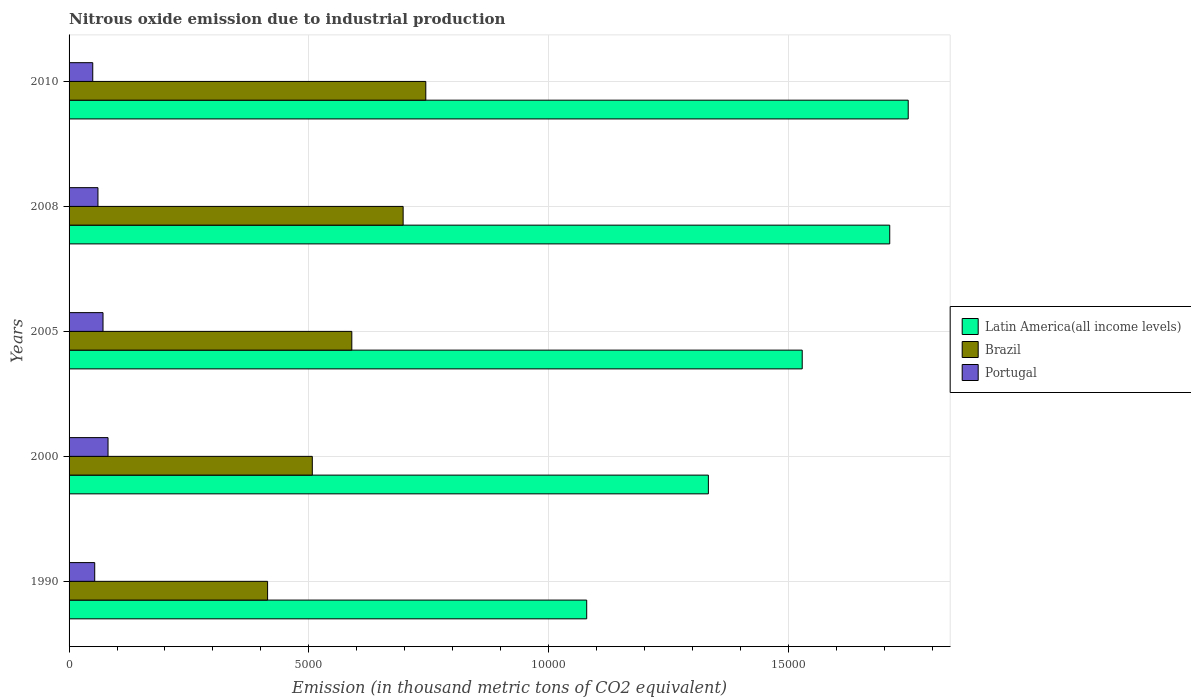How many different coloured bars are there?
Offer a terse response. 3. How many groups of bars are there?
Provide a succinct answer. 5. How many bars are there on the 5th tick from the top?
Give a very brief answer. 3. How many bars are there on the 2nd tick from the bottom?
Provide a short and direct response. 3. In how many cases, is the number of bars for a given year not equal to the number of legend labels?
Your answer should be compact. 0. What is the amount of nitrous oxide emitted in Latin America(all income levels) in 1990?
Offer a terse response. 1.08e+04. Across all years, what is the maximum amount of nitrous oxide emitted in Brazil?
Keep it short and to the point. 7440.7. Across all years, what is the minimum amount of nitrous oxide emitted in Latin America(all income levels)?
Your answer should be compact. 1.08e+04. In which year was the amount of nitrous oxide emitted in Portugal maximum?
Offer a very short reply. 2000. In which year was the amount of nitrous oxide emitted in Latin America(all income levels) minimum?
Ensure brevity in your answer.  1990. What is the total amount of nitrous oxide emitted in Latin America(all income levels) in the graph?
Offer a very short reply. 7.40e+04. What is the difference between the amount of nitrous oxide emitted in Latin America(all income levels) in 2005 and that in 2008?
Your response must be concise. -1825.4. What is the difference between the amount of nitrous oxide emitted in Brazil in 2010 and the amount of nitrous oxide emitted in Latin America(all income levels) in 2005?
Offer a very short reply. -7851.4. What is the average amount of nitrous oxide emitted in Latin America(all income levels) per year?
Your response must be concise. 1.48e+04. In the year 2005, what is the difference between the amount of nitrous oxide emitted in Latin America(all income levels) and amount of nitrous oxide emitted in Portugal?
Give a very brief answer. 1.46e+04. What is the ratio of the amount of nitrous oxide emitted in Latin America(all income levels) in 1990 to that in 2005?
Provide a succinct answer. 0.71. Is the difference between the amount of nitrous oxide emitted in Latin America(all income levels) in 2008 and 2010 greater than the difference between the amount of nitrous oxide emitted in Portugal in 2008 and 2010?
Provide a succinct answer. No. What is the difference between the highest and the second highest amount of nitrous oxide emitted in Brazil?
Provide a succinct answer. 472.8. What is the difference between the highest and the lowest amount of nitrous oxide emitted in Latin America(all income levels)?
Offer a terse response. 6706.3. In how many years, is the amount of nitrous oxide emitted in Portugal greater than the average amount of nitrous oxide emitted in Portugal taken over all years?
Keep it short and to the point. 2. What does the 2nd bar from the top in 2010 represents?
Your answer should be compact. Brazil. How many bars are there?
Your answer should be compact. 15. Are all the bars in the graph horizontal?
Offer a terse response. Yes. How many years are there in the graph?
Ensure brevity in your answer.  5. Are the values on the major ticks of X-axis written in scientific E-notation?
Your answer should be compact. No. Where does the legend appear in the graph?
Your answer should be very brief. Center right. How many legend labels are there?
Offer a very short reply. 3. What is the title of the graph?
Provide a short and direct response. Nitrous oxide emission due to industrial production. Does "East Asia (all income levels)" appear as one of the legend labels in the graph?
Make the answer very short. No. What is the label or title of the X-axis?
Offer a very short reply. Emission (in thousand metric tons of CO2 equivalent). What is the Emission (in thousand metric tons of CO2 equivalent) in Latin America(all income levels) in 1990?
Your answer should be compact. 1.08e+04. What is the Emission (in thousand metric tons of CO2 equivalent) in Brazil in 1990?
Make the answer very short. 4140.8. What is the Emission (in thousand metric tons of CO2 equivalent) of Portugal in 1990?
Give a very brief answer. 534.9. What is the Emission (in thousand metric tons of CO2 equivalent) of Latin America(all income levels) in 2000?
Provide a succinct answer. 1.33e+04. What is the Emission (in thousand metric tons of CO2 equivalent) in Brazil in 2000?
Ensure brevity in your answer.  5073.4. What is the Emission (in thousand metric tons of CO2 equivalent) in Portugal in 2000?
Give a very brief answer. 812.7. What is the Emission (in thousand metric tons of CO2 equivalent) of Latin America(all income levels) in 2005?
Provide a succinct answer. 1.53e+04. What is the Emission (in thousand metric tons of CO2 equivalent) of Brazil in 2005?
Your answer should be very brief. 5897.3. What is the Emission (in thousand metric tons of CO2 equivalent) in Portugal in 2005?
Provide a short and direct response. 708. What is the Emission (in thousand metric tons of CO2 equivalent) in Latin America(all income levels) in 2008?
Offer a very short reply. 1.71e+04. What is the Emission (in thousand metric tons of CO2 equivalent) in Brazil in 2008?
Offer a very short reply. 6967.9. What is the Emission (in thousand metric tons of CO2 equivalent) in Portugal in 2008?
Your answer should be very brief. 602.5. What is the Emission (in thousand metric tons of CO2 equivalent) of Latin America(all income levels) in 2010?
Your response must be concise. 1.75e+04. What is the Emission (in thousand metric tons of CO2 equivalent) of Brazil in 2010?
Ensure brevity in your answer.  7440.7. What is the Emission (in thousand metric tons of CO2 equivalent) in Portugal in 2010?
Your response must be concise. 494. Across all years, what is the maximum Emission (in thousand metric tons of CO2 equivalent) of Latin America(all income levels)?
Keep it short and to the point. 1.75e+04. Across all years, what is the maximum Emission (in thousand metric tons of CO2 equivalent) in Brazil?
Give a very brief answer. 7440.7. Across all years, what is the maximum Emission (in thousand metric tons of CO2 equivalent) of Portugal?
Your answer should be compact. 812.7. Across all years, what is the minimum Emission (in thousand metric tons of CO2 equivalent) in Latin America(all income levels)?
Your response must be concise. 1.08e+04. Across all years, what is the minimum Emission (in thousand metric tons of CO2 equivalent) in Brazil?
Your answer should be very brief. 4140.8. Across all years, what is the minimum Emission (in thousand metric tons of CO2 equivalent) of Portugal?
Your answer should be compact. 494. What is the total Emission (in thousand metric tons of CO2 equivalent) of Latin America(all income levels) in the graph?
Offer a terse response. 7.40e+04. What is the total Emission (in thousand metric tons of CO2 equivalent) in Brazil in the graph?
Provide a succinct answer. 2.95e+04. What is the total Emission (in thousand metric tons of CO2 equivalent) in Portugal in the graph?
Ensure brevity in your answer.  3152.1. What is the difference between the Emission (in thousand metric tons of CO2 equivalent) in Latin America(all income levels) in 1990 and that in 2000?
Your response must be concise. -2538. What is the difference between the Emission (in thousand metric tons of CO2 equivalent) of Brazil in 1990 and that in 2000?
Offer a terse response. -932.6. What is the difference between the Emission (in thousand metric tons of CO2 equivalent) in Portugal in 1990 and that in 2000?
Your answer should be compact. -277.8. What is the difference between the Emission (in thousand metric tons of CO2 equivalent) in Latin America(all income levels) in 1990 and that in 2005?
Ensure brevity in your answer.  -4495.3. What is the difference between the Emission (in thousand metric tons of CO2 equivalent) of Brazil in 1990 and that in 2005?
Ensure brevity in your answer.  -1756.5. What is the difference between the Emission (in thousand metric tons of CO2 equivalent) of Portugal in 1990 and that in 2005?
Offer a very short reply. -173.1. What is the difference between the Emission (in thousand metric tons of CO2 equivalent) of Latin America(all income levels) in 1990 and that in 2008?
Give a very brief answer. -6320.7. What is the difference between the Emission (in thousand metric tons of CO2 equivalent) in Brazil in 1990 and that in 2008?
Give a very brief answer. -2827.1. What is the difference between the Emission (in thousand metric tons of CO2 equivalent) of Portugal in 1990 and that in 2008?
Provide a short and direct response. -67.6. What is the difference between the Emission (in thousand metric tons of CO2 equivalent) in Latin America(all income levels) in 1990 and that in 2010?
Make the answer very short. -6706.3. What is the difference between the Emission (in thousand metric tons of CO2 equivalent) of Brazil in 1990 and that in 2010?
Provide a short and direct response. -3299.9. What is the difference between the Emission (in thousand metric tons of CO2 equivalent) in Portugal in 1990 and that in 2010?
Provide a short and direct response. 40.9. What is the difference between the Emission (in thousand metric tons of CO2 equivalent) in Latin America(all income levels) in 2000 and that in 2005?
Your response must be concise. -1957.3. What is the difference between the Emission (in thousand metric tons of CO2 equivalent) in Brazil in 2000 and that in 2005?
Offer a very short reply. -823.9. What is the difference between the Emission (in thousand metric tons of CO2 equivalent) of Portugal in 2000 and that in 2005?
Provide a succinct answer. 104.7. What is the difference between the Emission (in thousand metric tons of CO2 equivalent) of Latin America(all income levels) in 2000 and that in 2008?
Offer a very short reply. -3782.7. What is the difference between the Emission (in thousand metric tons of CO2 equivalent) in Brazil in 2000 and that in 2008?
Make the answer very short. -1894.5. What is the difference between the Emission (in thousand metric tons of CO2 equivalent) of Portugal in 2000 and that in 2008?
Provide a short and direct response. 210.2. What is the difference between the Emission (in thousand metric tons of CO2 equivalent) of Latin America(all income levels) in 2000 and that in 2010?
Offer a terse response. -4168.3. What is the difference between the Emission (in thousand metric tons of CO2 equivalent) of Brazil in 2000 and that in 2010?
Provide a succinct answer. -2367.3. What is the difference between the Emission (in thousand metric tons of CO2 equivalent) of Portugal in 2000 and that in 2010?
Provide a short and direct response. 318.7. What is the difference between the Emission (in thousand metric tons of CO2 equivalent) of Latin America(all income levels) in 2005 and that in 2008?
Your answer should be very brief. -1825.4. What is the difference between the Emission (in thousand metric tons of CO2 equivalent) of Brazil in 2005 and that in 2008?
Offer a terse response. -1070.6. What is the difference between the Emission (in thousand metric tons of CO2 equivalent) in Portugal in 2005 and that in 2008?
Your answer should be very brief. 105.5. What is the difference between the Emission (in thousand metric tons of CO2 equivalent) in Latin America(all income levels) in 2005 and that in 2010?
Provide a short and direct response. -2211. What is the difference between the Emission (in thousand metric tons of CO2 equivalent) in Brazil in 2005 and that in 2010?
Make the answer very short. -1543.4. What is the difference between the Emission (in thousand metric tons of CO2 equivalent) in Portugal in 2005 and that in 2010?
Provide a short and direct response. 214. What is the difference between the Emission (in thousand metric tons of CO2 equivalent) of Latin America(all income levels) in 2008 and that in 2010?
Offer a terse response. -385.6. What is the difference between the Emission (in thousand metric tons of CO2 equivalent) of Brazil in 2008 and that in 2010?
Your answer should be very brief. -472.8. What is the difference between the Emission (in thousand metric tons of CO2 equivalent) in Portugal in 2008 and that in 2010?
Provide a succinct answer. 108.5. What is the difference between the Emission (in thousand metric tons of CO2 equivalent) in Latin America(all income levels) in 1990 and the Emission (in thousand metric tons of CO2 equivalent) in Brazil in 2000?
Offer a terse response. 5723.4. What is the difference between the Emission (in thousand metric tons of CO2 equivalent) in Latin America(all income levels) in 1990 and the Emission (in thousand metric tons of CO2 equivalent) in Portugal in 2000?
Offer a terse response. 9984.1. What is the difference between the Emission (in thousand metric tons of CO2 equivalent) of Brazil in 1990 and the Emission (in thousand metric tons of CO2 equivalent) of Portugal in 2000?
Offer a terse response. 3328.1. What is the difference between the Emission (in thousand metric tons of CO2 equivalent) in Latin America(all income levels) in 1990 and the Emission (in thousand metric tons of CO2 equivalent) in Brazil in 2005?
Provide a short and direct response. 4899.5. What is the difference between the Emission (in thousand metric tons of CO2 equivalent) in Latin America(all income levels) in 1990 and the Emission (in thousand metric tons of CO2 equivalent) in Portugal in 2005?
Offer a very short reply. 1.01e+04. What is the difference between the Emission (in thousand metric tons of CO2 equivalent) of Brazil in 1990 and the Emission (in thousand metric tons of CO2 equivalent) of Portugal in 2005?
Ensure brevity in your answer.  3432.8. What is the difference between the Emission (in thousand metric tons of CO2 equivalent) in Latin America(all income levels) in 1990 and the Emission (in thousand metric tons of CO2 equivalent) in Brazil in 2008?
Ensure brevity in your answer.  3828.9. What is the difference between the Emission (in thousand metric tons of CO2 equivalent) of Latin America(all income levels) in 1990 and the Emission (in thousand metric tons of CO2 equivalent) of Portugal in 2008?
Make the answer very short. 1.02e+04. What is the difference between the Emission (in thousand metric tons of CO2 equivalent) in Brazil in 1990 and the Emission (in thousand metric tons of CO2 equivalent) in Portugal in 2008?
Offer a very short reply. 3538.3. What is the difference between the Emission (in thousand metric tons of CO2 equivalent) in Latin America(all income levels) in 1990 and the Emission (in thousand metric tons of CO2 equivalent) in Brazil in 2010?
Your response must be concise. 3356.1. What is the difference between the Emission (in thousand metric tons of CO2 equivalent) in Latin America(all income levels) in 1990 and the Emission (in thousand metric tons of CO2 equivalent) in Portugal in 2010?
Provide a succinct answer. 1.03e+04. What is the difference between the Emission (in thousand metric tons of CO2 equivalent) in Brazil in 1990 and the Emission (in thousand metric tons of CO2 equivalent) in Portugal in 2010?
Your answer should be compact. 3646.8. What is the difference between the Emission (in thousand metric tons of CO2 equivalent) of Latin America(all income levels) in 2000 and the Emission (in thousand metric tons of CO2 equivalent) of Brazil in 2005?
Offer a very short reply. 7437.5. What is the difference between the Emission (in thousand metric tons of CO2 equivalent) of Latin America(all income levels) in 2000 and the Emission (in thousand metric tons of CO2 equivalent) of Portugal in 2005?
Provide a short and direct response. 1.26e+04. What is the difference between the Emission (in thousand metric tons of CO2 equivalent) in Brazil in 2000 and the Emission (in thousand metric tons of CO2 equivalent) in Portugal in 2005?
Your response must be concise. 4365.4. What is the difference between the Emission (in thousand metric tons of CO2 equivalent) of Latin America(all income levels) in 2000 and the Emission (in thousand metric tons of CO2 equivalent) of Brazil in 2008?
Make the answer very short. 6366.9. What is the difference between the Emission (in thousand metric tons of CO2 equivalent) of Latin America(all income levels) in 2000 and the Emission (in thousand metric tons of CO2 equivalent) of Portugal in 2008?
Provide a succinct answer. 1.27e+04. What is the difference between the Emission (in thousand metric tons of CO2 equivalent) in Brazil in 2000 and the Emission (in thousand metric tons of CO2 equivalent) in Portugal in 2008?
Offer a very short reply. 4470.9. What is the difference between the Emission (in thousand metric tons of CO2 equivalent) of Latin America(all income levels) in 2000 and the Emission (in thousand metric tons of CO2 equivalent) of Brazil in 2010?
Provide a succinct answer. 5894.1. What is the difference between the Emission (in thousand metric tons of CO2 equivalent) of Latin America(all income levels) in 2000 and the Emission (in thousand metric tons of CO2 equivalent) of Portugal in 2010?
Provide a succinct answer. 1.28e+04. What is the difference between the Emission (in thousand metric tons of CO2 equivalent) in Brazil in 2000 and the Emission (in thousand metric tons of CO2 equivalent) in Portugal in 2010?
Your response must be concise. 4579.4. What is the difference between the Emission (in thousand metric tons of CO2 equivalent) of Latin America(all income levels) in 2005 and the Emission (in thousand metric tons of CO2 equivalent) of Brazil in 2008?
Your answer should be compact. 8324.2. What is the difference between the Emission (in thousand metric tons of CO2 equivalent) of Latin America(all income levels) in 2005 and the Emission (in thousand metric tons of CO2 equivalent) of Portugal in 2008?
Offer a very short reply. 1.47e+04. What is the difference between the Emission (in thousand metric tons of CO2 equivalent) in Brazil in 2005 and the Emission (in thousand metric tons of CO2 equivalent) in Portugal in 2008?
Make the answer very short. 5294.8. What is the difference between the Emission (in thousand metric tons of CO2 equivalent) in Latin America(all income levels) in 2005 and the Emission (in thousand metric tons of CO2 equivalent) in Brazil in 2010?
Offer a terse response. 7851.4. What is the difference between the Emission (in thousand metric tons of CO2 equivalent) of Latin America(all income levels) in 2005 and the Emission (in thousand metric tons of CO2 equivalent) of Portugal in 2010?
Your answer should be very brief. 1.48e+04. What is the difference between the Emission (in thousand metric tons of CO2 equivalent) of Brazil in 2005 and the Emission (in thousand metric tons of CO2 equivalent) of Portugal in 2010?
Your response must be concise. 5403.3. What is the difference between the Emission (in thousand metric tons of CO2 equivalent) of Latin America(all income levels) in 2008 and the Emission (in thousand metric tons of CO2 equivalent) of Brazil in 2010?
Ensure brevity in your answer.  9676.8. What is the difference between the Emission (in thousand metric tons of CO2 equivalent) of Latin America(all income levels) in 2008 and the Emission (in thousand metric tons of CO2 equivalent) of Portugal in 2010?
Provide a short and direct response. 1.66e+04. What is the difference between the Emission (in thousand metric tons of CO2 equivalent) of Brazil in 2008 and the Emission (in thousand metric tons of CO2 equivalent) of Portugal in 2010?
Provide a succinct answer. 6473.9. What is the average Emission (in thousand metric tons of CO2 equivalent) of Latin America(all income levels) per year?
Your answer should be very brief. 1.48e+04. What is the average Emission (in thousand metric tons of CO2 equivalent) of Brazil per year?
Make the answer very short. 5904.02. What is the average Emission (in thousand metric tons of CO2 equivalent) in Portugal per year?
Offer a terse response. 630.42. In the year 1990, what is the difference between the Emission (in thousand metric tons of CO2 equivalent) in Latin America(all income levels) and Emission (in thousand metric tons of CO2 equivalent) in Brazil?
Your answer should be very brief. 6656. In the year 1990, what is the difference between the Emission (in thousand metric tons of CO2 equivalent) of Latin America(all income levels) and Emission (in thousand metric tons of CO2 equivalent) of Portugal?
Your answer should be very brief. 1.03e+04. In the year 1990, what is the difference between the Emission (in thousand metric tons of CO2 equivalent) in Brazil and Emission (in thousand metric tons of CO2 equivalent) in Portugal?
Your response must be concise. 3605.9. In the year 2000, what is the difference between the Emission (in thousand metric tons of CO2 equivalent) in Latin America(all income levels) and Emission (in thousand metric tons of CO2 equivalent) in Brazil?
Provide a short and direct response. 8261.4. In the year 2000, what is the difference between the Emission (in thousand metric tons of CO2 equivalent) in Latin America(all income levels) and Emission (in thousand metric tons of CO2 equivalent) in Portugal?
Give a very brief answer. 1.25e+04. In the year 2000, what is the difference between the Emission (in thousand metric tons of CO2 equivalent) in Brazil and Emission (in thousand metric tons of CO2 equivalent) in Portugal?
Your answer should be compact. 4260.7. In the year 2005, what is the difference between the Emission (in thousand metric tons of CO2 equivalent) of Latin America(all income levels) and Emission (in thousand metric tons of CO2 equivalent) of Brazil?
Provide a short and direct response. 9394.8. In the year 2005, what is the difference between the Emission (in thousand metric tons of CO2 equivalent) of Latin America(all income levels) and Emission (in thousand metric tons of CO2 equivalent) of Portugal?
Provide a succinct answer. 1.46e+04. In the year 2005, what is the difference between the Emission (in thousand metric tons of CO2 equivalent) in Brazil and Emission (in thousand metric tons of CO2 equivalent) in Portugal?
Keep it short and to the point. 5189.3. In the year 2008, what is the difference between the Emission (in thousand metric tons of CO2 equivalent) in Latin America(all income levels) and Emission (in thousand metric tons of CO2 equivalent) in Brazil?
Keep it short and to the point. 1.01e+04. In the year 2008, what is the difference between the Emission (in thousand metric tons of CO2 equivalent) in Latin America(all income levels) and Emission (in thousand metric tons of CO2 equivalent) in Portugal?
Ensure brevity in your answer.  1.65e+04. In the year 2008, what is the difference between the Emission (in thousand metric tons of CO2 equivalent) of Brazil and Emission (in thousand metric tons of CO2 equivalent) of Portugal?
Ensure brevity in your answer.  6365.4. In the year 2010, what is the difference between the Emission (in thousand metric tons of CO2 equivalent) in Latin America(all income levels) and Emission (in thousand metric tons of CO2 equivalent) in Brazil?
Provide a short and direct response. 1.01e+04. In the year 2010, what is the difference between the Emission (in thousand metric tons of CO2 equivalent) in Latin America(all income levels) and Emission (in thousand metric tons of CO2 equivalent) in Portugal?
Offer a terse response. 1.70e+04. In the year 2010, what is the difference between the Emission (in thousand metric tons of CO2 equivalent) in Brazil and Emission (in thousand metric tons of CO2 equivalent) in Portugal?
Offer a very short reply. 6946.7. What is the ratio of the Emission (in thousand metric tons of CO2 equivalent) of Latin America(all income levels) in 1990 to that in 2000?
Your answer should be compact. 0.81. What is the ratio of the Emission (in thousand metric tons of CO2 equivalent) in Brazil in 1990 to that in 2000?
Give a very brief answer. 0.82. What is the ratio of the Emission (in thousand metric tons of CO2 equivalent) in Portugal in 1990 to that in 2000?
Offer a very short reply. 0.66. What is the ratio of the Emission (in thousand metric tons of CO2 equivalent) of Latin America(all income levels) in 1990 to that in 2005?
Your answer should be compact. 0.71. What is the ratio of the Emission (in thousand metric tons of CO2 equivalent) of Brazil in 1990 to that in 2005?
Make the answer very short. 0.7. What is the ratio of the Emission (in thousand metric tons of CO2 equivalent) of Portugal in 1990 to that in 2005?
Give a very brief answer. 0.76. What is the ratio of the Emission (in thousand metric tons of CO2 equivalent) in Latin America(all income levels) in 1990 to that in 2008?
Offer a terse response. 0.63. What is the ratio of the Emission (in thousand metric tons of CO2 equivalent) of Brazil in 1990 to that in 2008?
Give a very brief answer. 0.59. What is the ratio of the Emission (in thousand metric tons of CO2 equivalent) of Portugal in 1990 to that in 2008?
Keep it short and to the point. 0.89. What is the ratio of the Emission (in thousand metric tons of CO2 equivalent) of Latin America(all income levels) in 1990 to that in 2010?
Provide a short and direct response. 0.62. What is the ratio of the Emission (in thousand metric tons of CO2 equivalent) in Brazil in 1990 to that in 2010?
Your answer should be very brief. 0.56. What is the ratio of the Emission (in thousand metric tons of CO2 equivalent) of Portugal in 1990 to that in 2010?
Ensure brevity in your answer.  1.08. What is the ratio of the Emission (in thousand metric tons of CO2 equivalent) in Latin America(all income levels) in 2000 to that in 2005?
Provide a short and direct response. 0.87. What is the ratio of the Emission (in thousand metric tons of CO2 equivalent) of Brazil in 2000 to that in 2005?
Provide a short and direct response. 0.86. What is the ratio of the Emission (in thousand metric tons of CO2 equivalent) in Portugal in 2000 to that in 2005?
Keep it short and to the point. 1.15. What is the ratio of the Emission (in thousand metric tons of CO2 equivalent) in Latin America(all income levels) in 2000 to that in 2008?
Keep it short and to the point. 0.78. What is the ratio of the Emission (in thousand metric tons of CO2 equivalent) in Brazil in 2000 to that in 2008?
Your answer should be very brief. 0.73. What is the ratio of the Emission (in thousand metric tons of CO2 equivalent) of Portugal in 2000 to that in 2008?
Make the answer very short. 1.35. What is the ratio of the Emission (in thousand metric tons of CO2 equivalent) of Latin America(all income levels) in 2000 to that in 2010?
Keep it short and to the point. 0.76. What is the ratio of the Emission (in thousand metric tons of CO2 equivalent) of Brazil in 2000 to that in 2010?
Your answer should be compact. 0.68. What is the ratio of the Emission (in thousand metric tons of CO2 equivalent) in Portugal in 2000 to that in 2010?
Make the answer very short. 1.65. What is the ratio of the Emission (in thousand metric tons of CO2 equivalent) of Latin America(all income levels) in 2005 to that in 2008?
Provide a succinct answer. 0.89. What is the ratio of the Emission (in thousand metric tons of CO2 equivalent) in Brazil in 2005 to that in 2008?
Your answer should be very brief. 0.85. What is the ratio of the Emission (in thousand metric tons of CO2 equivalent) of Portugal in 2005 to that in 2008?
Give a very brief answer. 1.18. What is the ratio of the Emission (in thousand metric tons of CO2 equivalent) of Latin America(all income levels) in 2005 to that in 2010?
Give a very brief answer. 0.87. What is the ratio of the Emission (in thousand metric tons of CO2 equivalent) of Brazil in 2005 to that in 2010?
Ensure brevity in your answer.  0.79. What is the ratio of the Emission (in thousand metric tons of CO2 equivalent) in Portugal in 2005 to that in 2010?
Offer a terse response. 1.43. What is the ratio of the Emission (in thousand metric tons of CO2 equivalent) in Brazil in 2008 to that in 2010?
Offer a very short reply. 0.94. What is the ratio of the Emission (in thousand metric tons of CO2 equivalent) in Portugal in 2008 to that in 2010?
Keep it short and to the point. 1.22. What is the difference between the highest and the second highest Emission (in thousand metric tons of CO2 equivalent) in Latin America(all income levels)?
Provide a short and direct response. 385.6. What is the difference between the highest and the second highest Emission (in thousand metric tons of CO2 equivalent) in Brazil?
Offer a very short reply. 472.8. What is the difference between the highest and the second highest Emission (in thousand metric tons of CO2 equivalent) in Portugal?
Your answer should be compact. 104.7. What is the difference between the highest and the lowest Emission (in thousand metric tons of CO2 equivalent) of Latin America(all income levels)?
Give a very brief answer. 6706.3. What is the difference between the highest and the lowest Emission (in thousand metric tons of CO2 equivalent) in Brazil?
Your answer should be very brief. 3299.9. What is the difference between the highest and the lowest Emission (in thousand metric tons of CO2 equivalent) of Portugal?
Provide a short and direct response. 318.7. 